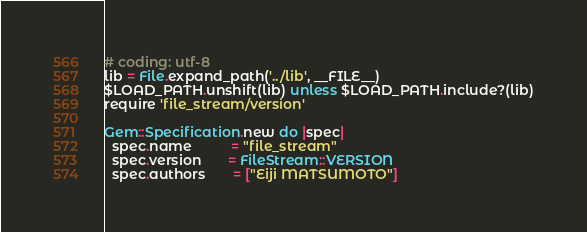Convert code to text. <code><loc_0><loc_0><loc_500><loc_500><_Ruby_># coding: utf-8
lib = File.expand_path('../lib', __FILE__)
$LOAD_PATH.unshift(lib) unless $LOAD_PATH.include?(lib)
require 'file_stream/version'

Gem::Specification.new do |spec|
  spec.name          = "file_stream"
  spec.version       = FileStream::VERSION
  spec.authors       = ["Eiji MATSUMOTO"]</code> 